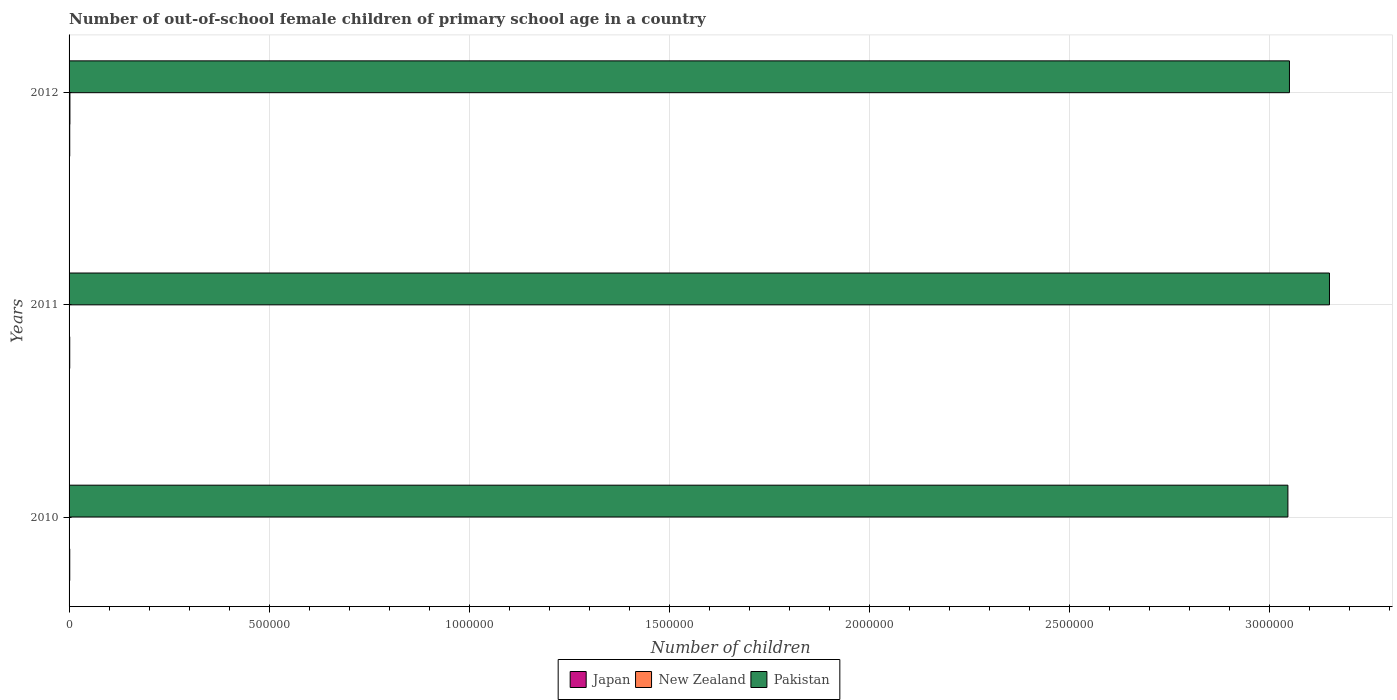How many different coloured bars are there?
Ensure brevity in your answer.  3. Are the number of bars per tick equal to the number of legend labels?
Provide a short and direct response. Yes. How many bars are there on the 3rd tick from the bottom?
Ensure brevity in your answer.  3. In how many cases, is the number of bars for a given year not equal to the number of legend labels?
Your answer should be very brief. 0. What is the number of out-of-school female children in New Zealand in 2010?
Offer a terse response. 600. Across all years, what is the maximum number of out-of-school female children in Pakistan?
Offer a terse response. 3.15e+06. Across all years, what is the minimum number of out-of-school female children in Japan?
Keep it short and to the point. 1651. In which year was the number of out-of-school female children in Japan minimum?
Your answer should be very brief. 2012. What is the total number of out-of-school female children in New Zealand in the graph?
Offer a terse response. 3430. What is the difference between the number of out-of-school female children in New Zealand in 2010 and that in 2012?
Provide a succinct answer. -1518. What is the difference between the number of out-of-school female children in Japan in 2010 and the number of out-of-school female children in New Zealand in 2012?
Your answer should be compact. -425. What is the average number of out-of-school female children in Japan per year?
Make the answer very short. 1671. In the year 2011, what is the difference between the number of out-of-school female children in New Zealand and number of out-of-school female children in Pakistan?
Offer a very short reply. -3.15e+06. In how many years, is the number of out-of-school female children in Pakistan greater than 1500000 ?
Provide a succinct answer. 3. What is the ratio of the number of out-of-school female children in New Zealand in 2011 to that in 2012?
Make the answer very short. 0.34. Is the number of out-of-school female children in Japan in 2011 less than that in 2012?
Offer a very short reply. No. What is the difference between the highest and the second highest number of out-of-school female children in New Zealand?
Offer a terse response. 1406. What is the difference between the highest and the lowest number of out-of-school female children in Pakistan?
Provide a short and direct response. 1.04e+05. In how many years, is the number of out-of-school female children in New Zealand greater than the average number of out-of-school female children in New Zealand taken over all years?
Give a very brief answer. 1. Is the sum of the number of out-of-school female children in Pakistan in 2010 and 2011 greater than the maximum number of out-of-school female children in Japan across all years?
Make the answer very short. Yes. What does the 2nd bar from the top in 2012 represents?
Your answer should be very brief. New Zealand. How many years are there in the graph?
Ensure brevity in your answer.  3. What is the difference between two consecutive major ticks on the X-axis?
Ensure brevity in your answer.  5.00e+05. Does the graph contain grids?
Keep it short and to the point. Yes. What is the title of the graph?
Make the answer very short. Number of out-of-school female children of primary school age in a country. What is the label or title of the X-axis?
Offer a very short reply. Number of children. What is the Number of children of Japan in 2010?
Your response must be concise. 1693. What is the Number of children in New Zealand in 2010?
Keep it short and to the point. 600. What is the Number of children of Pakistan in 2010?
Offer a very short reply. 3.05e+06. What is the Number of children in Japan in 2011?
Keep it short and to the point. 1669. What is the Number of children in New Zealand in 2011?
Provide a short and direct response. 712. What is the Number of children of Pakistan in 2011?
Make the answer very short. 3.15e+06. What is the Number of children of Japan in 2012?
Give a very brief answer. 1651. What is the Number of children in New Zealand in 2012?
Offer a very short reply. 2118. What is the Number of children of Pakistan in 2012?
Your answer should be very brief. 3.05e+06. Across all years, what is the maximum Number of children in Japan?
Offer a very short reply. 1693. Across all years, what is the maximum Number of children in New Zealand?
Your response must be concise. 2118. Across all years, what is the maximum Number of children of Pakistan?
Your response must be concise. 3.15e+06. Across all years, what is the minimum Number of children of Japan?
Provide a succinct answer. 1651. Across all years, what is the minimum Number of children in New Zealand?
Offer a terse response. 600. Across all years, what is the minimum Number of children in Pakistan?
Your response must be concise. 3.05e+06. What is the total Number of children in Japan in the graph?
Your answer should be compact. 5013. What is the total Number of children of New Zealand in the graph?
Your answer should be compact. 3430. What is the total Number of children in Pakistan in the graph?
Make the answer very short. 9.25e+06. What is the difference between the Number of children of Japan in 2010 and that in 2011?
Offer a terse response. 24. What is the difference between the Number of children of New Zealand in 2010 and that in 2011?
Provide a short and direct response. -112. What is the difference between the Number of children in Pakistan in 2010 and that in 2011?
Make the answer very short. -1.04e+05. What is the difference between the Number of children in New Zealand in 2010 and that in 2012?
Offer a terse response. -1518. What is the difference between the Number of children of Pakistan in 2010 and that in 2012?
Offer a very short reply. -3886. What is the difference between the Number of children of Japan in 2011 and that in 2012?
Provide a short and direct response. 18. What is the difference between the Number of children of New Zealand in 2011 and that in 2012?
Give a very brief answer. -1406. What is the difference between the Number of children in Pakistan in 2011 and that in 2012?
Give a very brief answer. 1.00e+05. What is the difference between the Number of children in Japan in 2010 and the Number of children in New Zealand in 2011?
Provide a short and direct response. 981. What is the difference between the Number of children in Japan in 2010 and the Number of children in Pakistan in 2011?
Ensure brevity in your answer.  -3.15e+06. What is the difference between the Number of children of New Zealand in 2010 and the Number of children of Pakistan in 2011?
Offer a very short reply. -3.15e+06. What is the difference between the Number of children of Japan in 2010 and the Number of children of New Zealand in 2012?
Provide a succinct answer. -425. What is the difference between the Number of children in Japan in 2010 and the Number of children in Pakistan in 2012?
Your answer should be very brief. -3.05e+06. What is the difference between the Number of children of New Zealand in 2010 and the Number of children of Pakistan in 2012?
Offer a very short reply. -3.05e+06. What is the difference between the Number of children in Japan in 2011 and the Number of children in New Zealand in 2012?
Offer a very short reply. -449. What is the difference between the Number of children in Japan in 2011 and the Number of children in Pakistan in 2012?
Your answer should be compact. -3.05e+06. What is the difference between the Number of children in New Zealand in 2011 and the Number of children in Pakistan in 2012?
Your answer should be compact. -3.05e+06. What is the average Number of children of Japan per year?
Your answer should be very brief. 1671. What is the average Number of children in New Zealand per year?
Provide a short and direct response. 1143.33. What is the average Number of children of Pakistan per year?
Ensure brevity in your answer.  3.08e+06. In the year 2010, what is the difference between the Number of children in Japan and Number of children in New Zealand?
Make the answer very short. 1093. In the year 2010, what is the difference between the Number of children of Japan and Number of children of Pakistan?
Your answer should be compact. -3.05e+06. In the year 2010, what is the difference between the Number of children in New Zealand and Number of children in Pakistan?
Your answer should be very brief. -3.05e+06. In the year 2011, what is the difference between the Number of children in Japan and Number of children in New Zealand?
Make the answer very short. 957. In the year 2011, what is the difference between the Number of children of Japan and Number of children of Pakistan?
Ensure brevity in your answer.  -3.15e+06. In the year 2011, what is the difference between the Number of children of New Zealand and Number of children of Pakistan?
Your answer should be compact. -3.15e+06. In the year 2012, what is the difference between the Number of children of Japan and Number of children of New Zealand?
Provide a short and direct response. -467. In the year 2012, what is the difference between the Number of children in Japan and Number of children in Pakistan?
Offer a very short reply. -3.05e+06. In the year 2012, what is the difference between the Number of children in New Zealand and Number of children in Pakistan?
Keep it short and to the point. -3.05e+06. What is the ratio of the Number of children of Japan in 2010 to that in 2011?
Your answer should be compact. 1.01. What is the ratio of the Number of children of New Zealand in 2010 to that in 2011?
Ensure brevity in your answer.  0.84. What is the ratio of the Number of children in Pakistan in 2010 to that in 2011?
Offer a very short reply. 0.97. What is the ratio of the Number of children of Japan in 2010 to that in 2012?
Give a very brief answer. 1.03. What is the ratio of the Number of children of New Zealand in 2010 to that in 2012?
Your answer should be compact. 0.28. What is the ratio of the Number of children of Japan in 2011 to that in 2012?
Offer a very short reply. 1.01. What is the ratio of the Number of children in New Zealand in 2011 to that in 2012?
Keep it short and to the point. 0.34. What is the ratio of the Number of children of Pakistan in 2011 to that in 2012?
Keep it short and to the point. 1.03. What is the difference between the highest and the second highest Number of children in Japan?
Your response must be concise. 24. What is the difference between the highest and the second highest Number of children in New Zealand?
Your answer should be compact. 1406. What is the difference between the highest and the second highest Number of children in Pakistan?
Keep it short and to the point. 1.00e+05. What is the difference between the highest and the lowest Number of children in New Zealand?
Make the answer very short. 1518. What is the difference between the highest and the lowest Number of children of Pakistan?
Give a very brief answer. 1.04e+05. 